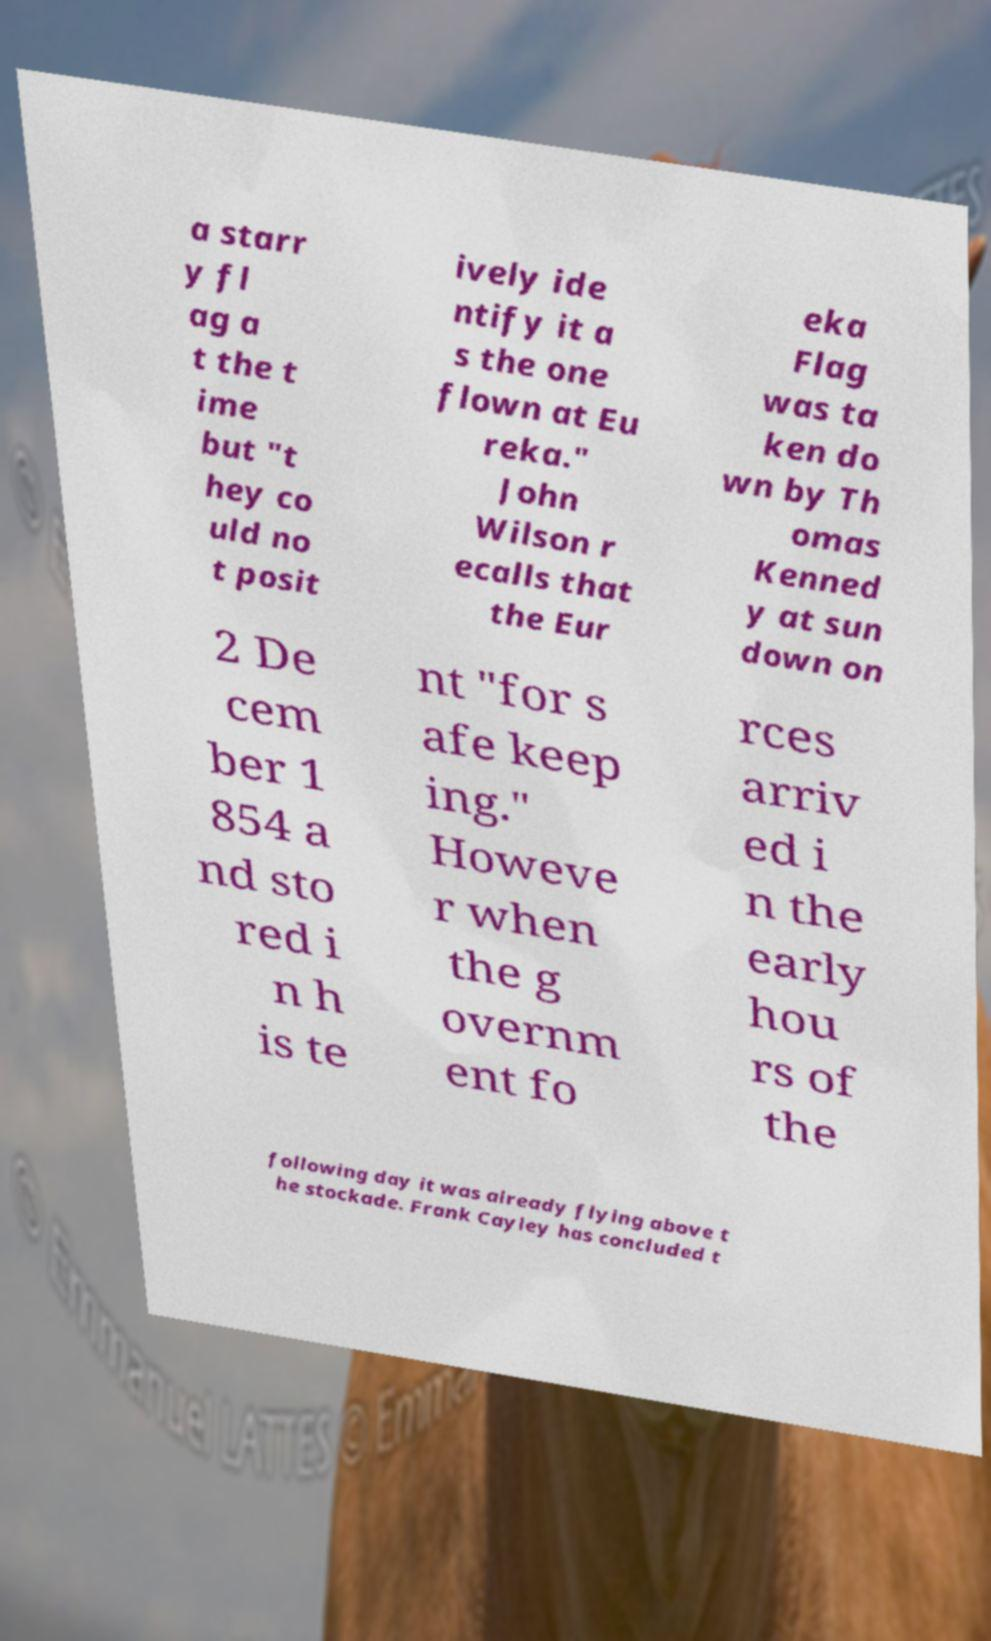Please identify and transcribe the text found in this image. a starr y fl ag a t the t ime but "t hey co uld no t posit ively ide ntify it a s the one flown at Eu reka." John Wilson r ecalls that the Eur eka Flag was ta ken do wn by Th omas Kenned y at sun down on 2 De cem ber 1 854 a nd sto red i n h is te nt "for s afe keep ing." Howeve r when the g overnm ent fo rces arriv ed i n the early hou rs of the following day it was already flying above t he stockade. Frank Cayley has concluded t 